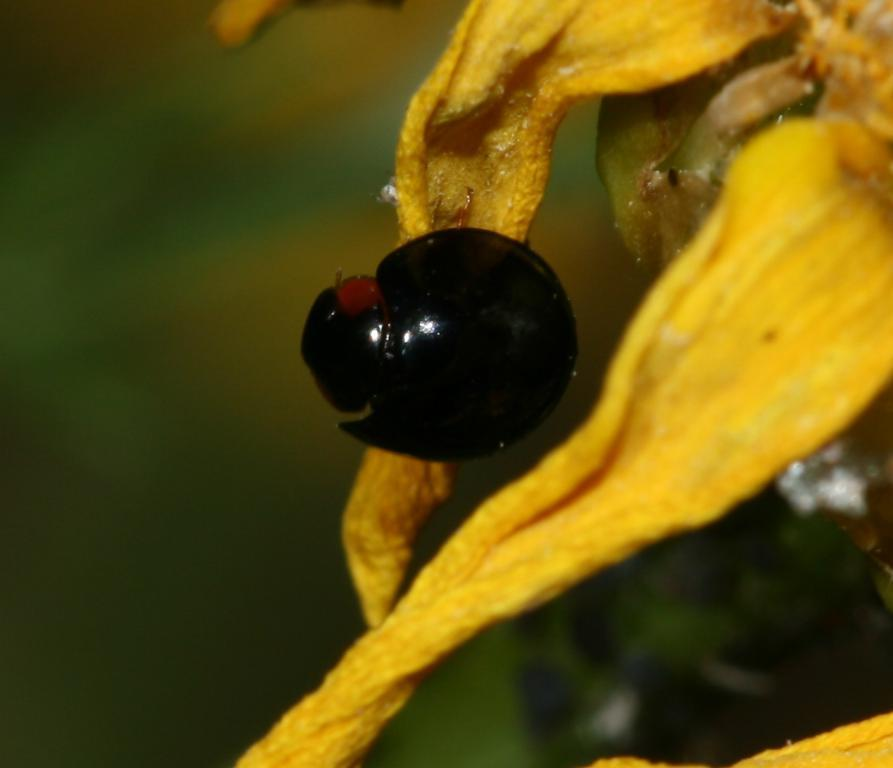What type of flower petals can be seen on the right side of the image? The petals are from a yellow flower. What color are the flower petals? The petals are in yellow color. What is located in the middle of the image? There appears to be an insect in the middle of the image. What color is the insect? The insect is in black color. Reasoning: Let' Let's think step by step in order to produce the conversation. We start by identifying the main subjects in the image, which are the flower petals and the insect. Then, we describe the colors of these subjects to provide more detail. Each question is designed to elicit a specific detail about the image that is known from the provided facts. Absurd Question/Answer: How does the monkey contribute to the loss of the fork in the image? There is no monkey or fork present in the image, so this scenario cannot be observed. 